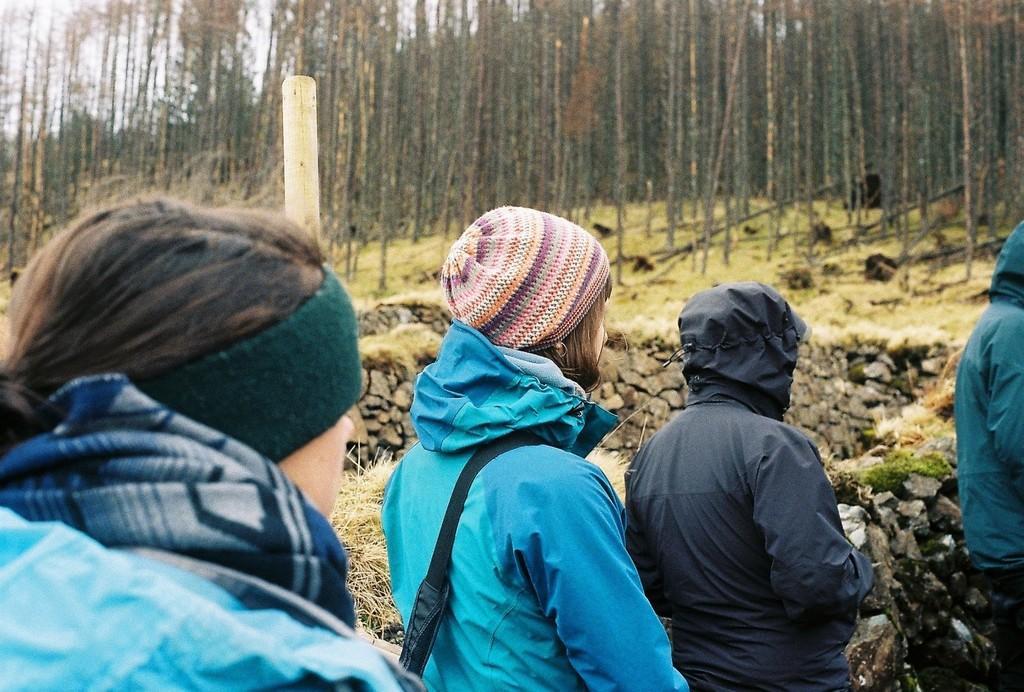Please provide a concise description of this image. In this image, we can see few people, stone wall, grass and pole. Background we can see walls, grass and trees. 